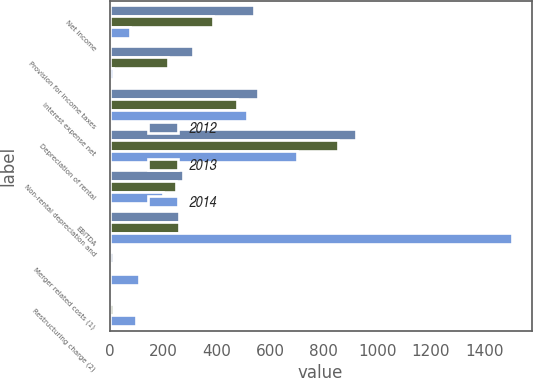Convert chart. <chart><loc_0><loc_0><loc_500><loc_500><stacked_bar_chart><ecel><fcel>Net income<fcel>Provision for income taxes<fcel>Interest expense net<fcel>Depreciation of rental<fcel>Non-rental depreciation and<fcel>EBITDA<fcel>Merger related costs (1)<fcel>Restructuring charge (2)<nl><fcel>2012<fcel>540<fcel>310<fcel>555<fcel>921<fcel>273<fcel>259.5<fcel>11<fcel>1<nl><fcel>2013<fcel>387<fcel>218<fcel>475<fcel>852<fcel>246<fcel>259.5<fcel>9<fcel>12<nl><fcel>2014<fcel>75<fcel>13<fcel>512<fcel>699<fcel>198<fcel>1501<fcel>111<fcel>99<nl></chart> 